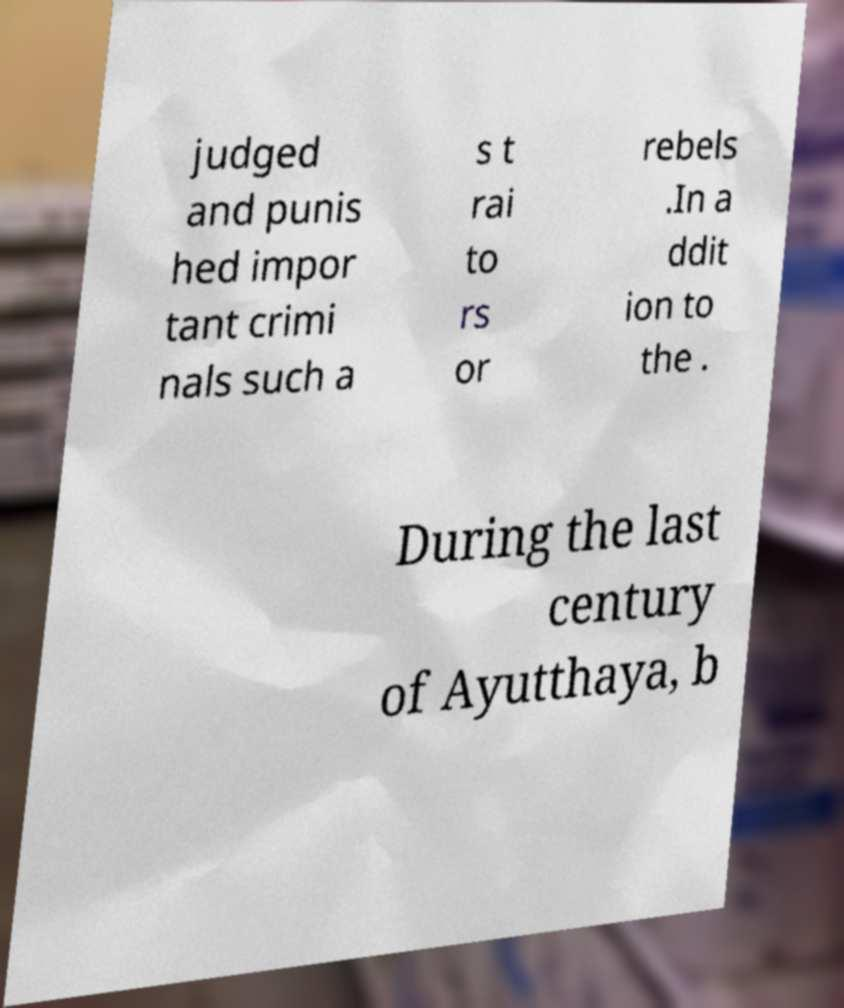For documentation purposes, I need the text within this image transcribed. Could you provide that? judged and punis hed impor tant crimi nals such a s t rai to rs or rebels .In a ddit ion to the . During the last century of Ayutthaya, b 